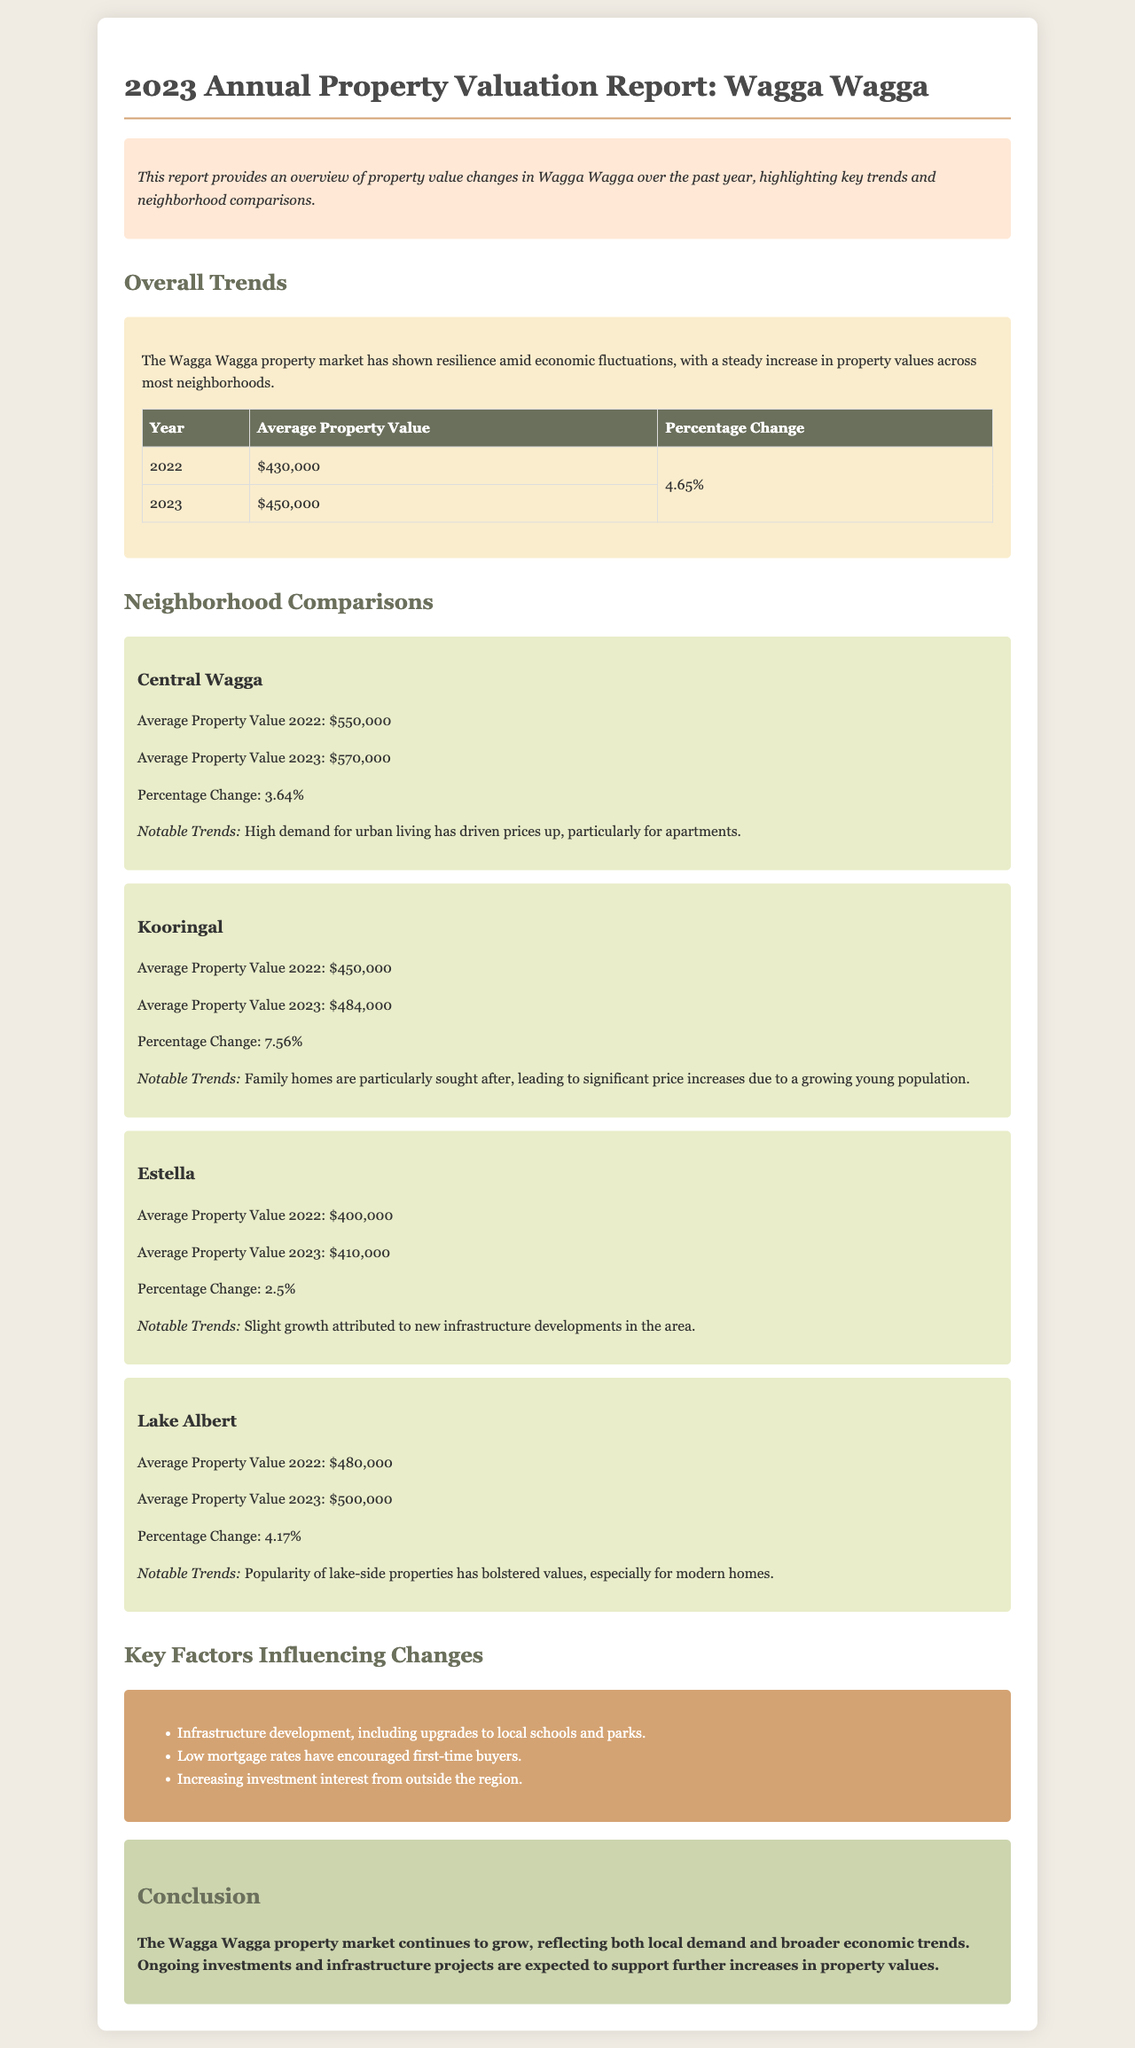What was the average property value in 2022? The average property value in 2022 is stated in the document as $430,000.
Answer: $430,000 What was the percentage change in property values from 2022 to 2023? The percentage change from 2022 to 2023 is 4.65%, which is highlighted in the overview trends section.
Answer: 4.65% What was the average property value for Central Wagga in 2023? The document states that the average property value for Central Wagga in 2023 is $570,000.
Answer: $570,000 Which neighborhood had the highest percentage change in property values? The neighborhood with the highest percentage change is Kooringal, with a percentage change of 7.56%.
Answer: Kooringal What are some key factors influencing property value changes? The document lists key factors such as infrastructure development and low mortgage rates.
Answer: Infrastructure development, low mortgage rates What was the average property value for Estella in 2022? The average property value for Estella in 2022 is specified as $400,000.
Answer: $400,000 What notable trend is mentioned for Lake Albert? The document notes that the popularity of lake-side properties has bolstered values in Lake Albert.
Answer: Popularity of lake-side properties What is the primary conclusion of the report? The conclusion states that the Wagga Wagga property market continues to grow.
Answer: Continues to grow 